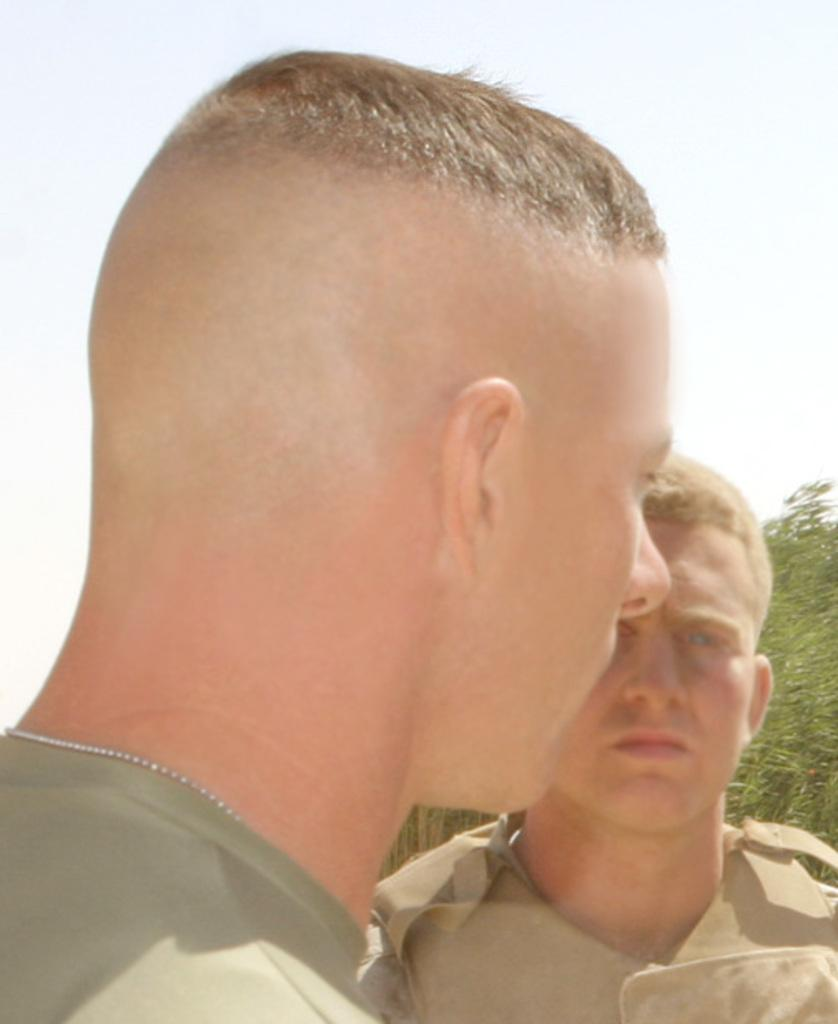How many people are present in the image? There are two men in the image. What can be seen in the background of the image? There are trees in the background of the image. What type of letter is the man holding in the image? There is no letter present in the image; only two men and trees in the background are visible. 